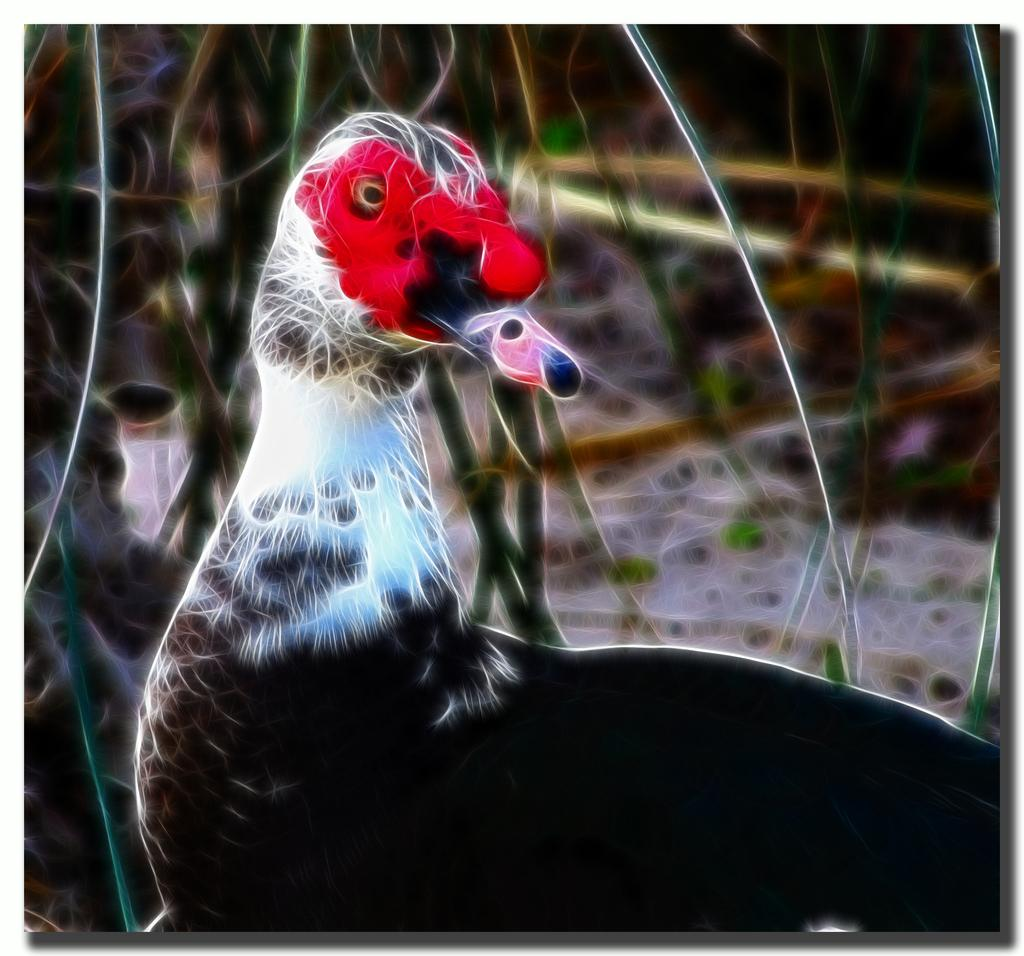What type of animal is featured in the image? The image contains an edited bird. What colors can be seen on the edited bird? The edited bird has white, blue, black, and red colors. What can be seen in the background of the image? There are plants in the background of the image. How many apples are hanging from the branches of the trees in the image? There are no apples present in the image; it features an edited bird and plants in the background. Can you describe the icicles hanging from the bird's beak in the image? There are no icicles present in the image; the edited bird has white, blue, black, and red colors. 